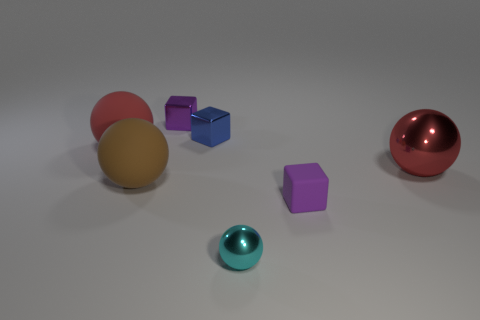There is a cube that is the same material as the brown thing; what is its color?
Keep it short and to the point. Purple. What number of tiny blue things are made of the same material as the cyan object?
Make the answer very short. 1. There is a big metal object; is it the same color as the big matte ball that is in front of the large red rubber thing?
Keep it short and to the point. No. What is the color of the large object that is on the right side of the tiny purple thing that is in front of the tiny purple shiny cube?
Provide a short and direct response. Red. What is the color of the ball that is the same size as the purple shiny object?
Your answer should be very brief. Cyan. Are there any blue metallic objects of the same shape as the cyan object?
Offer a very short reply. No. What shape is the small blue metal thing?
Your answer should be compact. Cube. Is the number of purple rubber things that are in front of the tiny metallic ball greater than the number of purple rubber things that are behind the red shiny ball?
Your answer should be very brief. No. What number of other objects are the same size as the purple rubber object?
Your response must be concise. 3. There is a sphere that is left of the tiny rubber thing and behind the big brown ball; what is its material?
Your response must be concise. Rubber. 